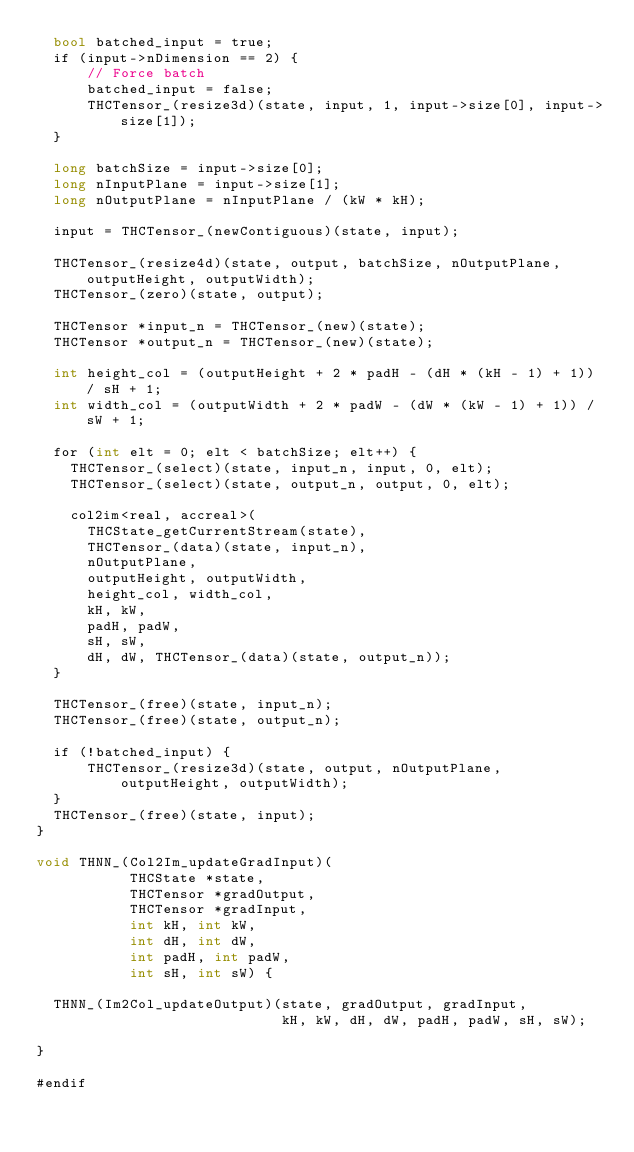<code> <loc_0><loc_0><loc_500><loc_500><_Cuda_>  bool batched_input = true;
  if (input->nDimension == 2) {
      // Force batch
      batched_input = false;
      THCTensor_(resize3d)(state, input, 1, input->size[0], input->size[1]);
  }

  long batchSize = input->size[0];
  long nInputPlane = input->size[1];
  long nOutputPlane = nInputPlane / (kW * kH);

  input = THCTensor_(newContiguous)(state, input);

  THCTensor_(resize4d)(state, output, batchSize, nOutputPlane, outputHeight, outputWidth);
  THCTensor_(zero)(state, output);

  THCTensor *input_n = THCTensor_(new)(state);
  THCTensor *output_n = THCTensor_(new)(state);

  int height_col = (outputHeight + 2 * padH - (dH * (kH - 1) + 1)) / sH + 1;
  int width_col = (outputWidth + 2 * padW - (dW * (kW - 1) + 1)) / sW + 1;

  for (int elt = 0; elt < batchSize; elt++) {
    THCTensor_(select)(state, input_n, input, 0, elt);
    THCTensor_(select)(state, output_n, output, 0, elt);

    col2im<real, accreal>(
      THCState_getCurrentStream(state),
      THCTensor_(data)(state, input_n),
      nOutputPlane,
      outputHeight, outputWidth,
      height_col, width_col,
      kH, kW,
      padH, padW,
      sH, sW,
      dH, dW, THCTensor_(data)(state, output_n));
  }

  THCTensor_(free)(state, input_n);
  THCTensor_(free)(state, output_n);

  if (!batched_input) {
      THCTensor_(resize3d)(state, output, nOutputPlane, outputHeight, outputWidth);
  }
  THCTensor_(free)(state, input);
}

void THNN_(Col2Im_updateGradInput)(
           THCState *state,
           THCTensor *gradOutput,
           THCTensor *gradInput,
           int kH, int kW,
           int dH, int dW,
           int padH, int padW,
           int sH, int sW) {

  THNN_(Im2Col_updateOutput)(state, gradOutput, gradInput,
                             kH, kW, dH, dW, padH, padW, sH, sW);

}

#endif
</code> 